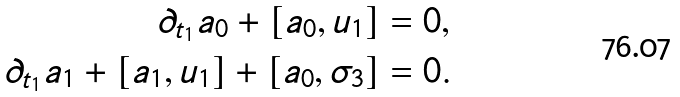<formula> <loc_0><loc_0><loc_500><loc_500>\partial _ { t _ { 1 } } a _ { 0 } + [ a _ { 0 } , u _ { 1 } ] & = 0 , \\ \partial _ { t _ { 1 } } a _ { 1 } + [ a _ { 1 } , u _ { 1 } ] + [ a _ { 0 } , \sigma _ { 3 } ] & = 0 .</formula> 